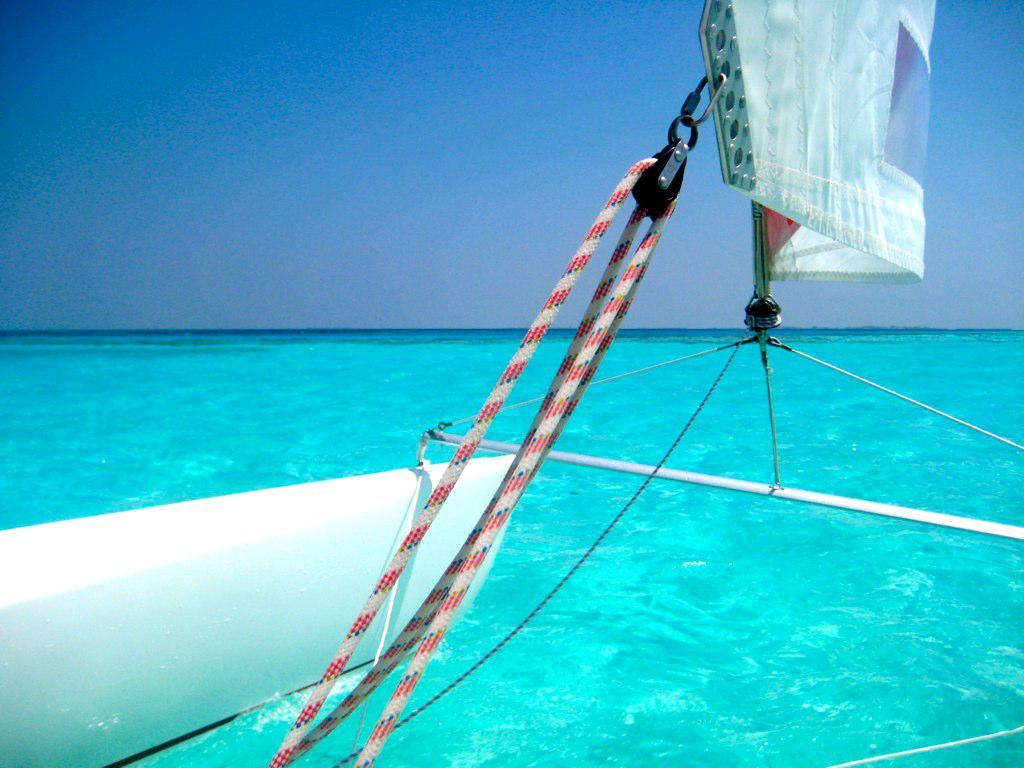What is the main subject of the image? The main subject of the image is a boat. How much of the boat can be seen in the image? The boat is partially visible (truncated) in the image. Where is the boat located in the image? The boat is in the water in the image. What else can be seen in the image besides the boat? The sky is visible in the image. What type of poison is being used to clean the boat in the image? There is no indication of any poison or cleaning activity in the image; it simply shows a boat in the water. How many chairs are visible on the boat in the image? There are no chairs visible on the boat in the image; only the boat itself is shown. 